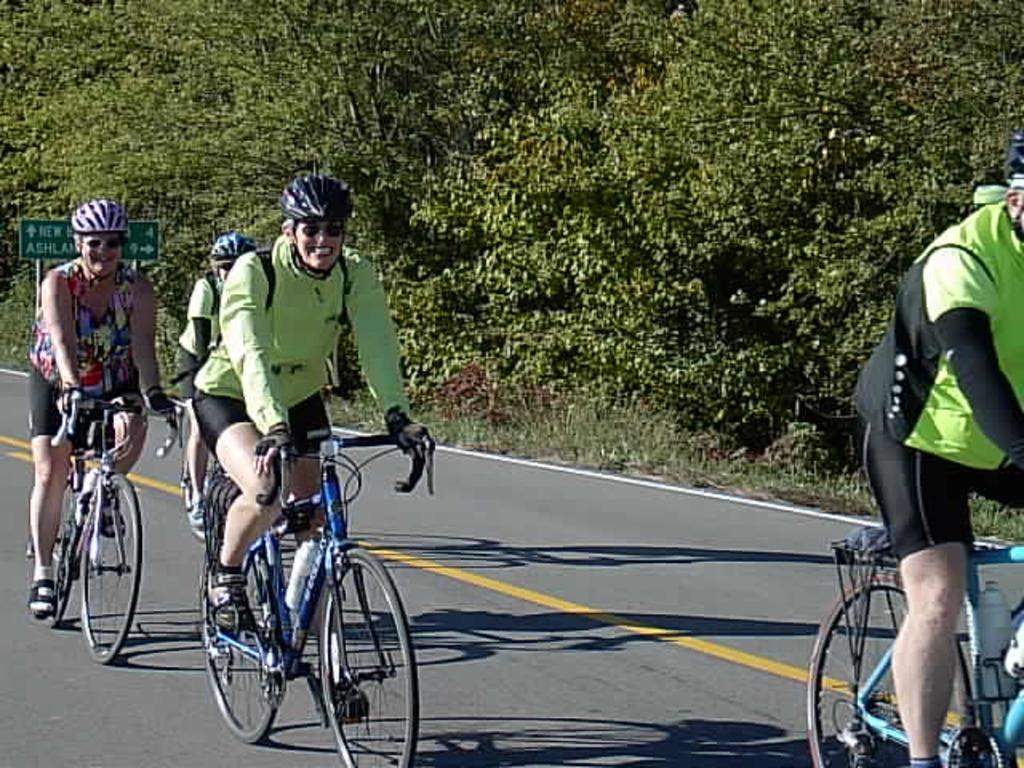In one or two sentences, can you explain what this image depicts? People are riding bicycles on the road and wore helmets. Background of the image we can see signboard, grass and trees. 